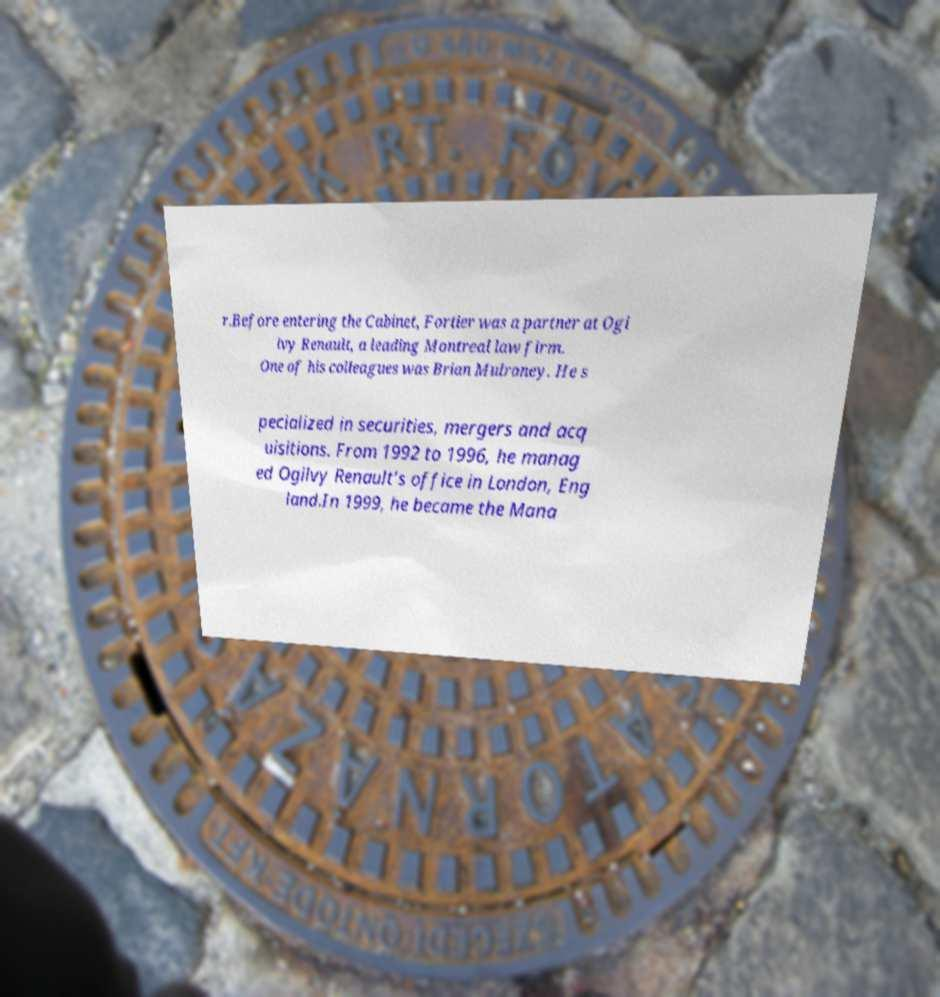For documentation purposes, I need the text within this image transcribed. Could you provide that? r.Before entering the Cabinet, Fortier was a partner at Ogi lvy Renault, a leading Montreal law firm. One of his colleagues was Brian Mulroney. He s pecialized in securities, mergers and acq uisitions. From 1992 to 1996, he manag ed Ogilvy Renault’s office in London, Eng land.In 1999, he became the Mana 